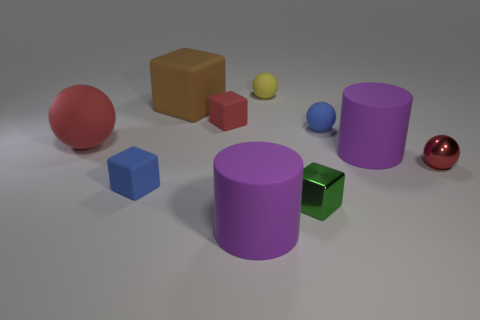Are there fewer purple matte cylinders than tiny purple spheres?
Offer a very short reply. No. Is the color of the shiny ball the same as the small metallic object that is left of the small red sphere?
Ensure brevity in your answer.  No. Are there an equal number of large red spheres in front of the metallic cube and green shiny objects that are behind the small blue sphere?
Your response must be concise. Yes. What number of other metallic things have the same shape as the brown object?
Make the answer very short. 1. Is there a rubber cylinder?
Make the answer very short. Yes. Is the material of the small red ball the same as the small cube behind the blue block?
Your response must be concise. No. There is a blue block that is the same size as the green metallic thing; what material is it?
Give a very brief answer. Rubber. Are there any big yellow balls that have the same material as the small red cube?
Keep it short and to the point. No. Is there a thing that is right of the red matte object right of the small blue rubber thing in front of the big red ball?
Your response must be concise. Yes. The red rubber object that is the same size as the green metal block is what shape?
Give a very brief answer. Cube. 